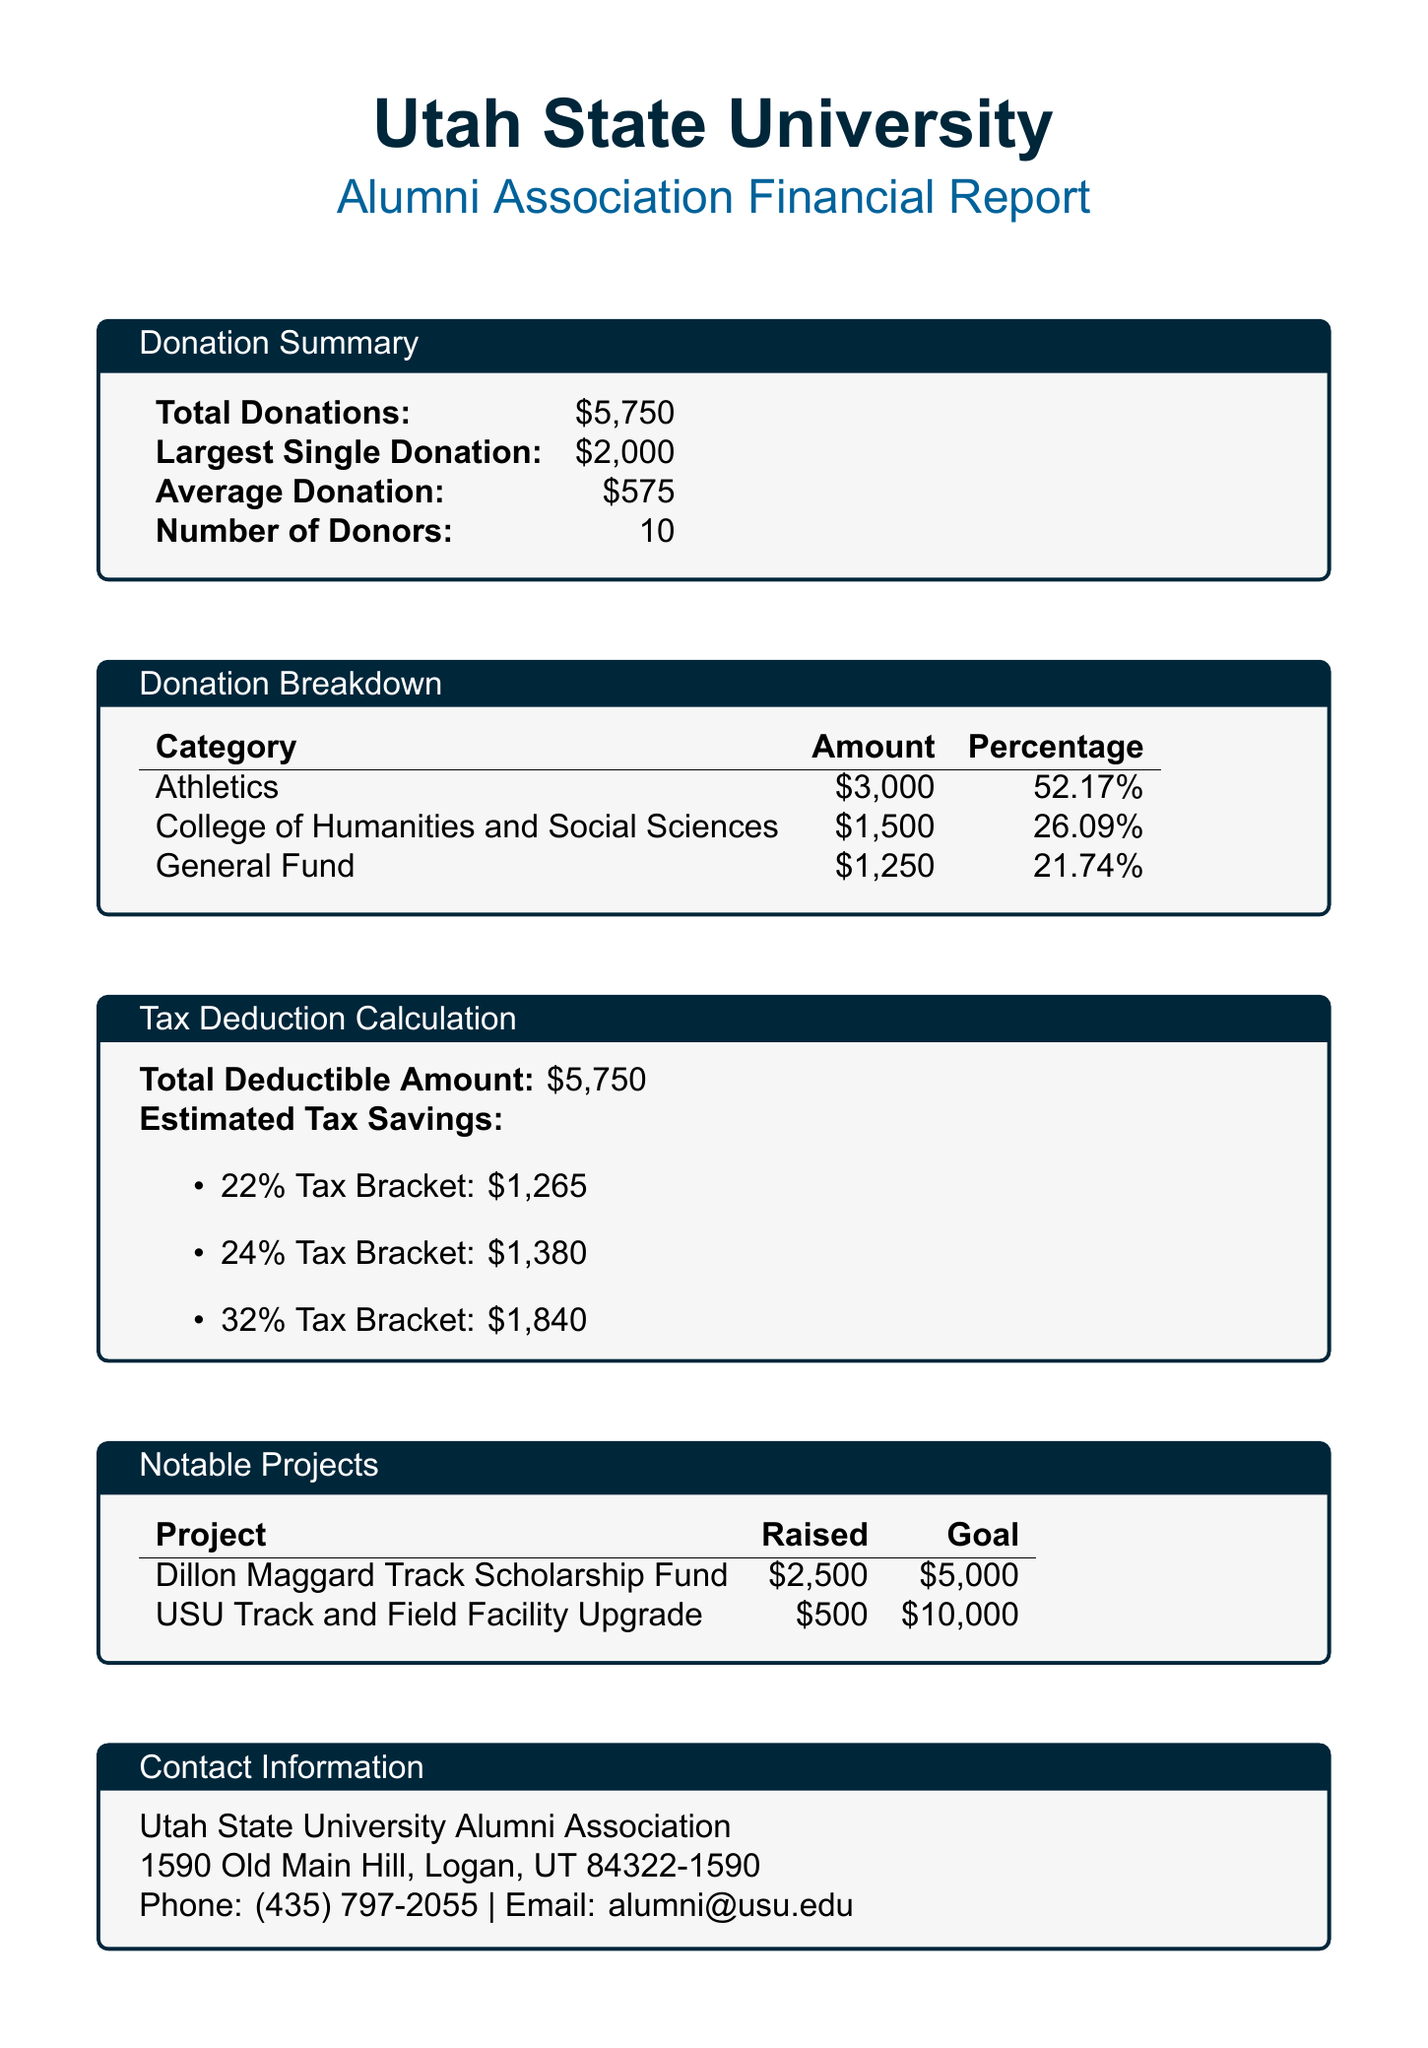What is the total amount of donations? The total amount of donations is explicitly stated in the document as $5,750.
Answer: $5,750 What is the largest single donation? The document specifies that the largest single donation made is $2,000.
Answer: $2,000 How much was raised for the Dillon Maggard Track Scholarship Fund? The document highlights that $2,500 was raised for the Dillon Maggard Track Scholarship Fund.
Answer: $2,500 What percentage of total donations went to Athletics? The donation breakdown shows that Athletics received 52.17% of the total donations.
Answer: 52.17% How much is the estimated tax savings in the 32% tax bracket? The document provides the estimated tax savings in the 32% tax bracket as $1,840.
Answer: $1,840 How many donors contributed to the total donations? According to the summary, there were a total of 10 donors.
Answer: 10 What is the goal amount for the Utah State University Track and Field Facility Upgrade? The document mentions that the goal for this project is $10,000.
Answer: $10,000 What is the contact email for the Utah State University Alumni Association? The email provided in the document for contact is alumni@usu.edu.
Answer: alumni@usu.edu What is the total deductible amount stated in the report? The total deductible amount is clearly stated as $5,750.
Answer: $5,750 